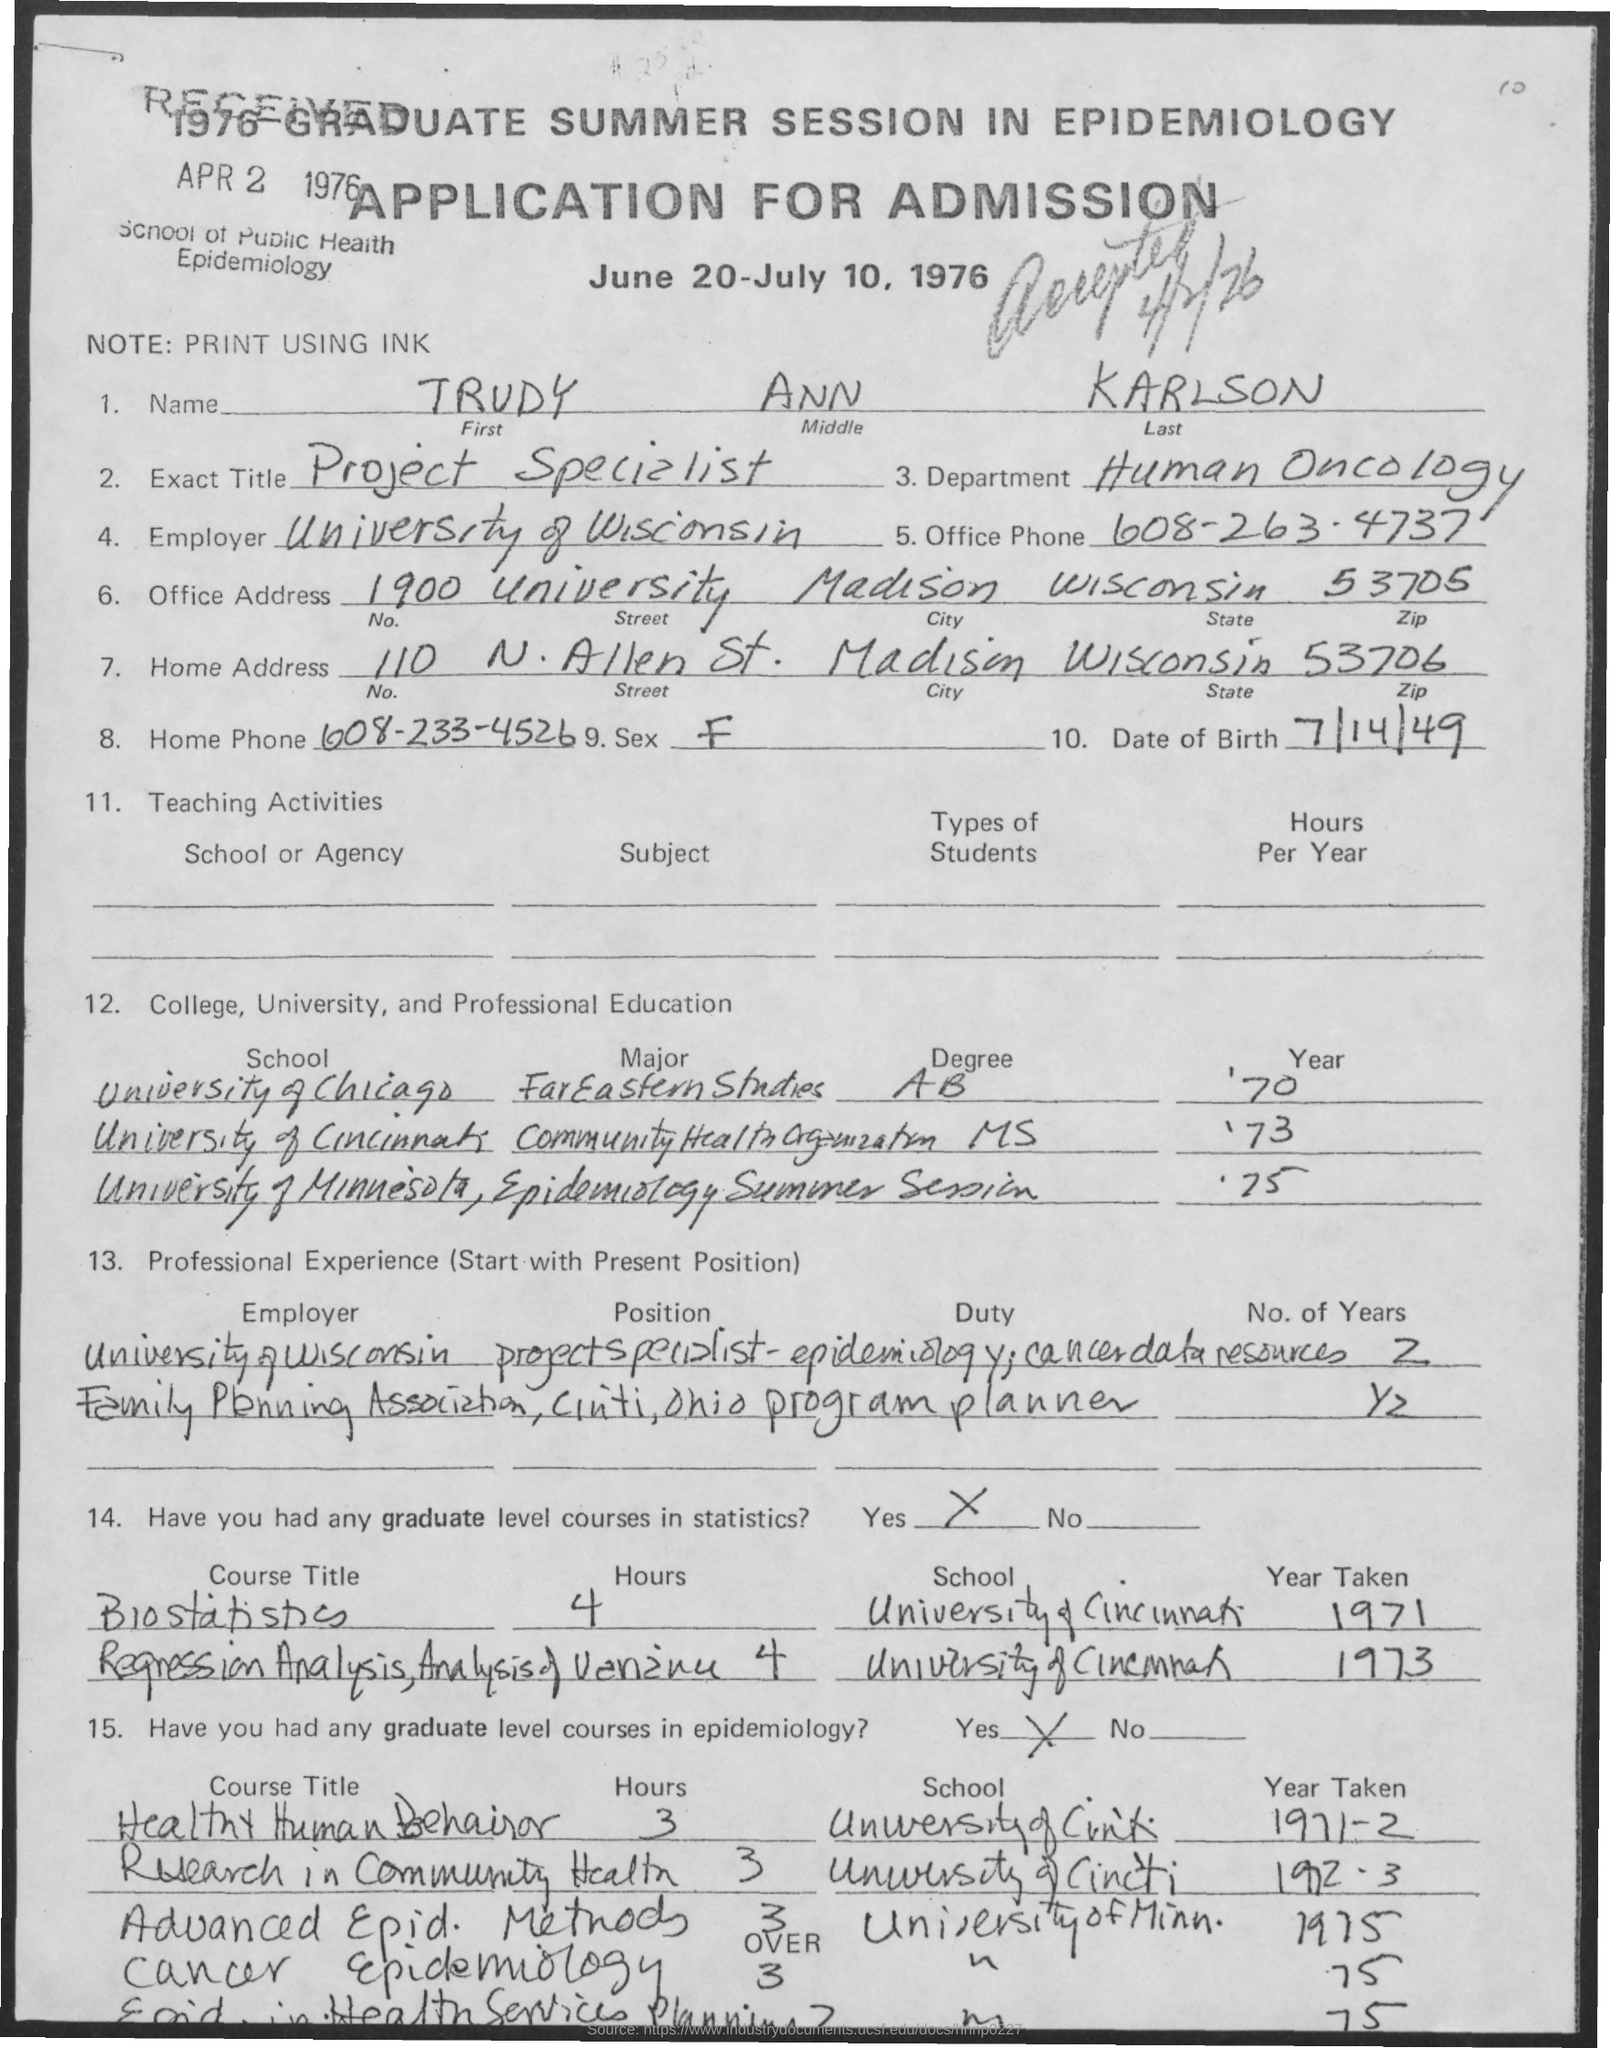What is the last name of the applicant?
Make the answer very short. KARLSON. What is the exact title of Trudy Ann Karlson?
Your answer should be very brief. Project Specialist. In which department, Trudy Ann Karlson works?
Provide a succinct answer. Human Oncology. Who is the current employer of Trudy Ann Karlson?
Offer a terse response. University of wisconsin. What is the Office Phone no mentioned in the application?
Offer a very short reply. 608-263-4737. What is the Date of Birth of Trudy Ann Karlson?
Provide a short and direct response. 7/14/49. What is the zipcode no mentioned in the office address?
Your response must be concise. 53705. What is the home phone no mentioned in the application?
Your response must be concise. 608-233-4526. In which university, Trudy Ann Karlson completed MS in community health organization?
Keep it short and to the point. University of cincinnati. 